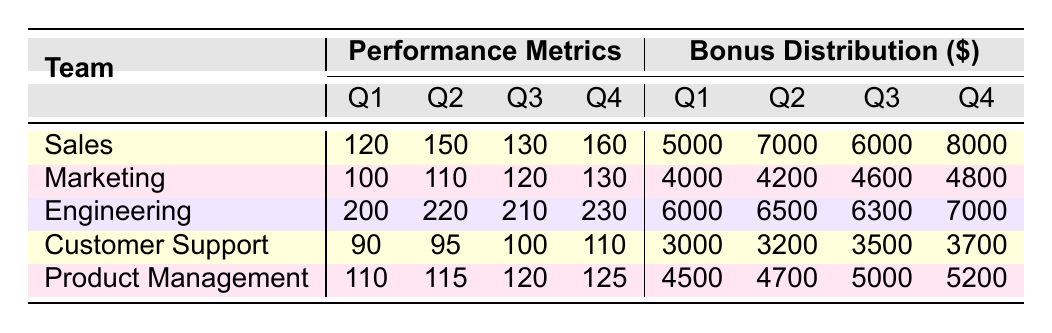What is the bonus distribution for the Sales team in Q4? According to the table, the bonus distribution for the Sales team for Q4 is listed as 8000.
Answer: 8000 Which team received the highest bonus in Q2? By examining the bonus distribution in Q2, Engineering received a bonus of 6500, which is the highest among all teams for that quarter.
Answer: Engineering What is the total performance metric for the Marketing team over all quarters? The performance metrics for the Marketing team are: Q1: 100, Q2: 110, Q3: 120, Q4: 130. Adding these values gives 100 + 110 + 120 + 130 = 460.
Answer: 460 Did the Customer Support team receive a higher bonus in Q3 than the Marketing team? The bonus for Customer Support in Q3 is 3500, while the Marketing team received 4600 in the same quarter. Since 3500 is less than 4600, the answer is no.
Answer: No What is the average bonus distribution for the Engineering team across all quarters? The bonus amounts for Engineering across all quarters are 6000, 6500, 6300, and 7000. Summing these amounts gives 6000 + 6500 + 6300 + 7000 = 25800, and dividing by the number of quarters (4) gives an average of 25800 / 4 = 6450.
Answer: 6450 Which team showed the highest performance metric in Q1? In Q1, the performance metrics were: Sales 120, Marketing 100, Engineering 200, Customer Support 90, Product Management 110. Engineering had the highest performance metric of 200.
Answer: Engineering Is the bonus for Product Management in Q4 more than 5000? The bonus for Product Management in Q4 is 5200, which is greater than 5000. Thus, the answer is yes.
Answer: Yes What are the performance metric values for the Sales team in Q3 and Q4 combined? The performance metric for Sales in Q3 is 130, and in Q4 it is 160. Adding these values gives 130 + 160 = 290.
Answer: 290 